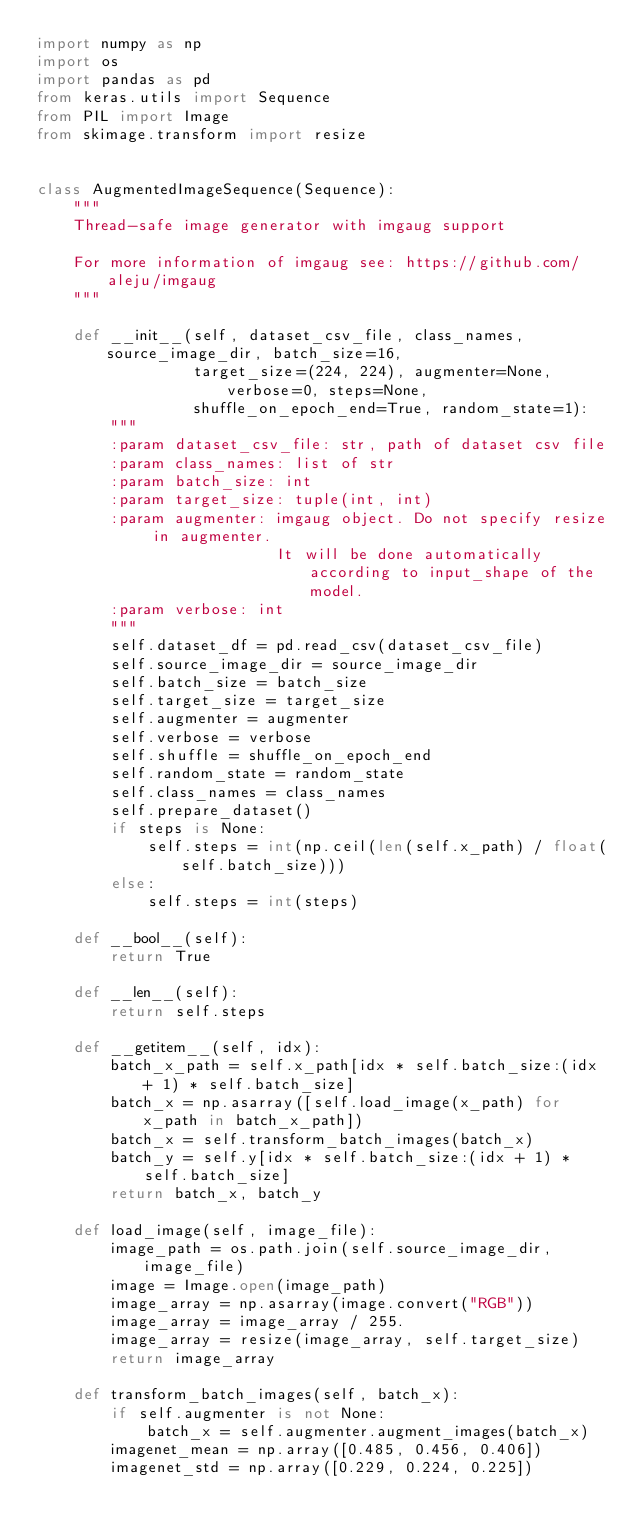<code> <loc_0><loc_0><loc_500><loc_500><_Python_>import numpy as np
import os
import pandas as pd
from keras.utils import Sequence
from PIL import Image
from skimage.transform import resize


class AugmentedImageSequence(Sequence):
    """
    Thread-safe image generator with imgaug support

    For more information of imgaug see: https://github.com/aleju/imgaug
    """

    def __init__(self, dataset_csv_file, class_names, source_image_dir, batch_size=16,
                 target_size=(224, 224), augmenter=None, verbose=0, steps=None,
                 shuffle_on_epoch_end=True, random_state=1):
        """
        :param dataset_csv_file: str, path of dataset csv file
        :param class_names: list of str
        :param batch_size: int
        :param target_size: tuple(int, int)
        :param augmenter: imgaug object. Do not specify resize in augmenter.
                          It will be done automatically according to input_shape of the model.
        :param verbose: int
        """
        self.dataset_df = pd.read_csv(dataset_csv_file)
        self.source_image_dir = source_image_dir
        self.batch_size = batch_size
        self.target_size = target_size
        self.augmenter = augmenter
        self.verbose = verbose
        self.shuffle = shuffle_on_epoch_end
        self.random_state = random_state
        self.class_names = class_names
        self.prepare_dataset()
        if steps is None:
            self.steps = int(np.ceil(len(self.x_path) / float(self.batch_size)))
        else:
            self.steps = int(steps)

    def __bool__(self):
        return True

    def __len__(self):
        return self.steps

    def __getitem__(self, idx):
        batch_x_path = self.x_path[idx * self.batch_size:(idx + 1) * self.batch_size]
        batch_x = np.asarray([self.load_image(x_path) for x_path in batch_x_path])
        batch_x = self.transform_batch_images(batch_x)
        batch_y = self.y[idx * self.batch_size:(idx + 1) * self.batch_size]
        return batch_x, batch_y

    def load_image(self, image_file):
        image_path = os.path.join(self.source_image_dir, image_file)
        image = Image.open(image_path)
        image_array = np.asarray(image.convert("RGB"))
        image_array = image_array / 255.
        image_array = resize(image_array, self.target_size)
        return image_array

    def transform_batch_images(self, batch_x):
        if self.augmenter is not None:
            batch_x = self.augmenter.augment_images(batch_x)
        imagenet_mean = np.array([0.485, 0.456, 0.406])
        imagenet_std = np.array([0.229, 0.224, 0.225])</code> 